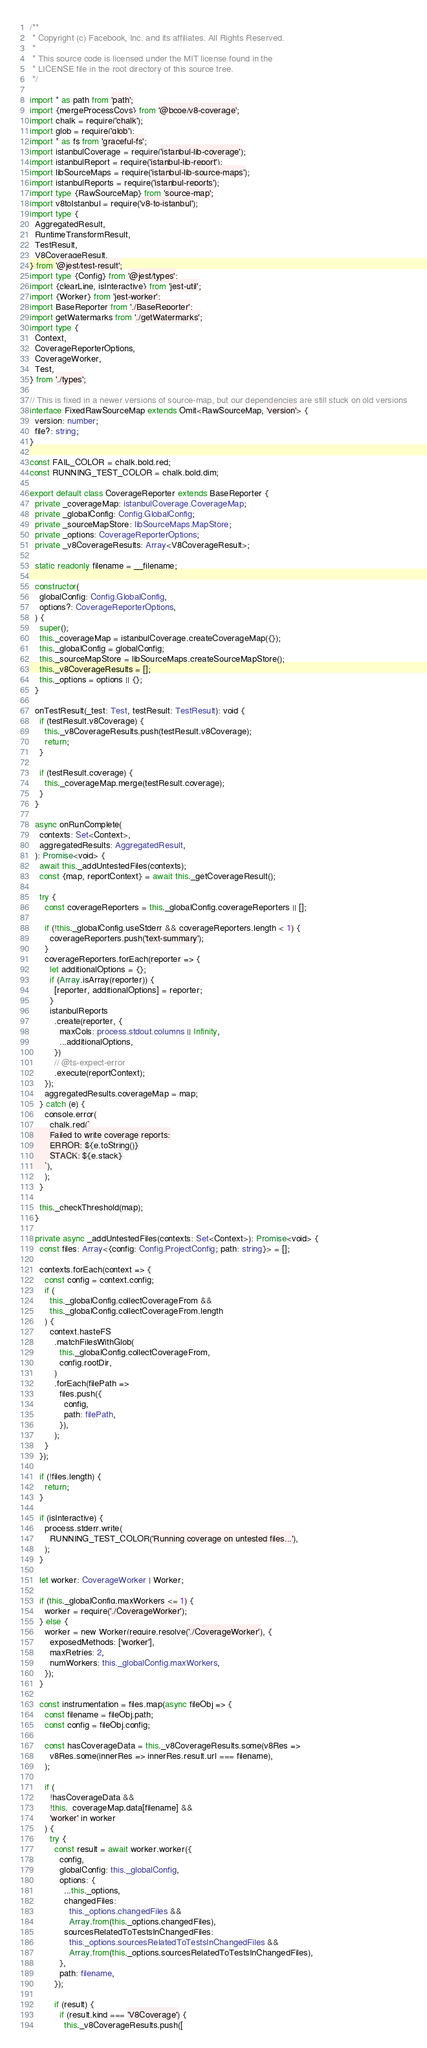<code> <loc_0><loc_0><loc_500><loc_500><_TypeScript_>/**
 * Copyright (c) Facebook, Inc. and its affiliates. All Rights Reserved.
 *
 * This source code is licensed under the MIT license found in the
 * LICENSE file in the root directory of this source tree.
 */

import * as path from 'path';
import {mergeProcessCovs} from '@bcoe/v8-coverage';
import chalk = require('chalk');
import glob = require('glob');
import * as fs from 'graceful-fs';
import istanbulCoverage = require('istanbul-lib-coverage');
import istanbulReport = require('istanbul-lib-report');
import libSourceMaps = require('istanbul-lib-source-maps');
import istanbulReports = require('istanbul-reports');
import type {RawSourceMap} from 'source-map';
import v8toIstanbul = require('v8-to-istanbul');
import type {
  AggregatedResult,
  RuntimeTransformResult,
  TestResult,
  V8CoverageResult,
} from '@jest/test-result';
import type {Config} from '@jest/types';
import {clearLine, isInteractive} from 'jest-util';
import {Worker} from 'jest-worker';
import BaseReporter from './BaseReporter';
import getWatermarks from './getWatermarks';
import type {
  Context,
  CoverageReporterOptions,
  CoverageWorker,
  Test,
} from './types';

// This is fixed in a newer versions of source-map, but our dependencies are still stuck on old versions
interface FixedRawSourceMap extends Omit<RawSourceMap, 'version'> {
  version: number;
  file?: string;
}

const FAIL_COLOR = chalk.bold.red;
const RUNNING_TEST_COLOR = chalk.bold.dim;

export default class CoverageReporter extends BaseReporter {
  private _coverageMap: istanbulCoverage.CoverageMap;
  private _globalConfig: Config.GlobalConfig;
  private _sourceMapStore: libSourceMaps.MapStore;
  private _options: CoverageReporterOptions;
  private _v8CoverageResults: Array<V8CoverageResult>;

  static readonly filename = __filename;

  constructor(
    globalConfig: Config.GlobalConfig,
    options?: CoverageReporterOptions,
  ) {
    super();
    this._coverageMap = istanbulCoverage.createCoverageMap({});
    this._globalConfig = globalConfig;
    this._sourceMapStore = libSourceMaps.createSourceMapStore();
    this._v8CoverageResults = [];
    this._options = options || {};
  }

  onTestResult(_test: Test, testResult: TestResult): void {
    if (testResult.v8Coverage) {
      this._v8CoverageResults.push(testResult.v8Coverage);
      return;
    }

    if (testResult.coverage) {
      this._coverageMap.merge(testResult.coverage);
    }
  }

  async onRunComplete(
    contexts: Set<Context>,
    aggregatedResults: AggregatedResult,
  ): Promise<void> {
    await this._addUntestedFiles(contexts);
    const {map, reportContext} = await this._getCoverageResult();

    try {
      const coverageReporters = this._globalConfig.coverageReporters || [];

      if (!this._globalConfig.useStderr && coverageReporters.length < 1) {
        coverageReporters.push('text-summary');
      }
      coverageReporters.forEach(reporter => {
        let additionalOptions = {};
        if (Array.isArray(reporter)) {
          [reporter, additionalOptions] = reporter;
        }
        istanbulReports
          .create(reporter, {
            maxCols: process.stdout.columns || Infinity,
            ...additionalOptions,
          })
          // @ts-expect-error
          .execute(reportContext);
      });
      aggregatedResults.coverageMap = map;
    } catch (e) {
      console.error(
        chalk.red(`
        Failed to write coverage reports:
        ERROR: ${e.toString()}
        STACK: ${e.stack}
      `),
      );
    }

    this._checkThreshold(map);
  }

  private async _addUntestedFiles(contexts: Set<Context>): Promise<void> {
    const files: Array<{config: Config.ProjectConfig; path: string}> = [];

    contexts.forEach(context => {
      const config = context.config;
      if (
        this._globalConfig.collectCoverageFrom &&
        this._globalConfig.collectCoverageFrom.length
      ) {
        context.hasteFS
          .matchFilesWithGlob(
            this._globalConfig.collectCoverageFrom,
            config.rootDir,
          )
          .forEach(filePath =>
            files.push({
              config,
              path: filePath,
            }),
          );
      }
    });

    if (!files.length) {
      return;
    }

    if (isInteractive) {
      process.stderr.write(
        RUNNING_TEST_COLOR('Running coverage on untested files...'),
      );
    }

    let worker: CoverageWorker | Worker;

    if (this._globalConfig.maxWorkers <= 1) {
      worker = require('./CoverageWorker');
    } else {
      worker = new Worker(require.resolve('./CoverageWorker'), {
        exposedMethods: ['worker'],
        maxRetries: 2,
        numWorkers: this._globalConfig.maxWorkers,
      });
    }

    const instrumentation = files.map(async fileObj => {
      const filename = fileObj.path;
      const config = fileObj.config;

      const hasCoverageData = this._v8CoverageResults.some(v8Res =>
        v8Res.some(innerRes => innerRes.result.url === filename),
      );

      if (
        !hasCoverageData &&
        !this._coverageMap.data[filename] &&
        'worker' in worker
      ) {
        try {
          const result = await worker.worker({
            config,
            globalConfig: this._globalConfig,
            options: {
              ...this._options,
              changedFiles:
                this._options.changedFiles &&
                Array.from(this._options.changedFiles),
              sourcesRelatedToTestsInChangedFiles:
                this._options.sourcesRelatedToTestsInChangedFiles &&
                Array.from(this._options.sourcesRelatedToTestsInChangedFiles),
            },
            path: filename,
          });

          if (result) {
            if (result.kind === 'V8Coverage') {
              this._v8CoverageResults.push([</code> 